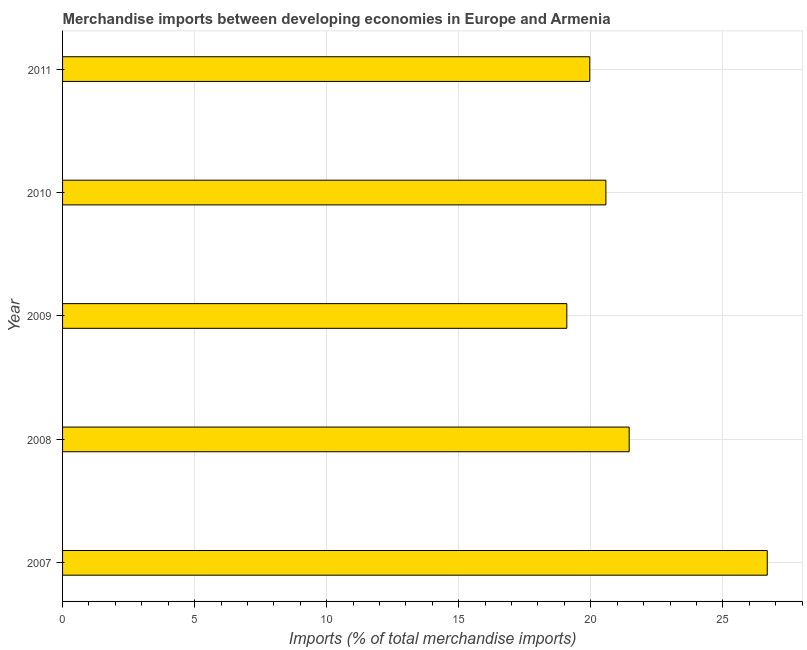Does the graph contain any zero values?
Keep it short and to the point. No. Does the graph contain grids?
Give a very brief answer. Yes. What is the title of the graph?
Keep it short and to the point. Merchandise imports between developing economies in Europe and Armenia. What is the label or title of the X-axis?
Offer a very short reply. Imports (% of total merchandise imports). What is the label or title of the Y-axis?
Provide a short and direct response. Year. What is the merchandise imports in 2008?
Provide a short and direct response. 21.45. Across all years, what is the maximum merchandise imports?
Your answer should be compact. 26.68. Across all years, what is the minimum merchandise imports?
Offer a terse response. 19.09. What is the sum of the merchandise imports?
Make the answer very short. 107.76. What is the difference between the merchandise imports in 2007 and 2009?
Give a very brief answer. 7.59. What is the average merchandise imports per year?
Ensure brevity in your answer.  21.55. What is the median merchandise imports?
Keep it short and to the point. 20.57. In how many years, is the merchandise imports greater than 16 %?
Offer a terse response. 5. What is the ratio of the merchandise imports in 2010 to that in 2011?
Your response must be concise. 1.03. Is the merchandise imports in 2008 less than that in 2009?
Your response must be concise. No. What is the difference between the highest and the second highest merchandise imports?
Offer a very short reply. 5.23. Is the sum of the merchandise imports in 2009 and 2010 greater than the maximum merchandise imports across all years?
Offer a very short reply. Yes. What is the difference between the highest and the lowest merchandise imports?
Your answer should be compact. 7.59. How many bars are there?
Your answer should be very brief. 5. Are all the bars in the graph horizontal?
Keep it short and to the point. Yes. How many years are there in the graph?
Offer a very short reply. 5. What is the Imports (% of total merchandise imports) in 2007?
Keep it short and to the point. 26.68. What is the Imports (% of total merchandise imports) in 2008?
Make the answer very short. 21.45. What is the Imports (% of total merchandise imports) of 2009?
Provide a succinct answer. 19.09. What is the Imports (% of total merchandise imports) of 2010?
Offer a very short reply. 20.57. What is the Imports (% of total merchandise imports) in 2011?
Offer a very short reply. 19.96. What is the difference between the Imports (% of total merchandise imports) in 2007 and 2008?
Your answer should be very brief. 5.23. What is the difference between the Imports (% of total merchandise imports) in 2007 and 2009?
Keep it short and to the point. 7.59. What is the difference between the Imports (% of total merchandise imports) in 2007 and 2010?
Ensure brevity in your answer.  6.11. What is the difference between the Imports (% of total merchandise imports) in 2007 and 2011?
Your response must be concise. 6.72. What is the difference between the Imports (% of total merchandise imports) in 2008 and 2009?
Make the answer very short. 2.36. What is the difference between the Imports (% of total merchandise imports) in 2008 and 2010?
Give a very brief answer. 0.88. What is the difference between the Imports (% of total merchandise imports) in 2008 and 2011?
Provide a succinct answer. 1.49. What is the difference between the Imports (% of total merchandise imports) in 2009 and 2010?
Offer a terse response. -1.48. What is the difference between the Imports (% of total merchandise imports) in 2009 and 2011?
Keep it short and to the point. -0.87. What is the difference between the Imports (% of total merchandise imports) in 2010 and 2011?
Your answer should be very brief. 0.61. What is the ratio of the Imports (% of total merchandise imports) in 2007 to that in 2008?
Your answer should be compact. 1.24. What is the ratio of the Imports (% of total merchandise imports) in 2007 to that in 2009?
Your answer should be compact. 1.4. What is the ratio of the Imports (% of total merchandise imports) in 2007 to that in 2010?
Your response must be concise. 1.3. What is the ratio of the Imports (% of total merchandise imports) in 2007 to that in 2011?
Your answer should be compact. 1.34. What is the ratio of the Imports (% of total merchandise imports) in 2008 to that in 2009?
Make the answer very short. 1.12. What is the ratio of the Imports (% of total merchandise imports) in 2008 to that in 2010?
Provide a short and direct response. 1.04. What is the ratio of the Imports (% of total merchandise imports) in 2008 to that in 2011?
Ensure brevity in your answer.  1.07. What is the ratio of the Imports (% of total merchandise imports) in 2009 to that in 2010?
Offer a terse response. 0.93. What is the ratio of the Imports (% of total merchandise imports) in 2009 to that in 2011?
Ensure brevity in your answer.  0.96. What is the ratio of the Imports (% of total merchandise imports) in 2010 to that in 2011?
Your answer should be compact. 1.03. 